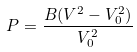Convert formula to latex. <formula><loc_0><loc_0><loc_500><loc_500>P = \frac { B ( V ^ { 2 } - V _ { 0 } ^ { 2 } ) } { V _ { 0 } ^ { 2 } }</formula> 